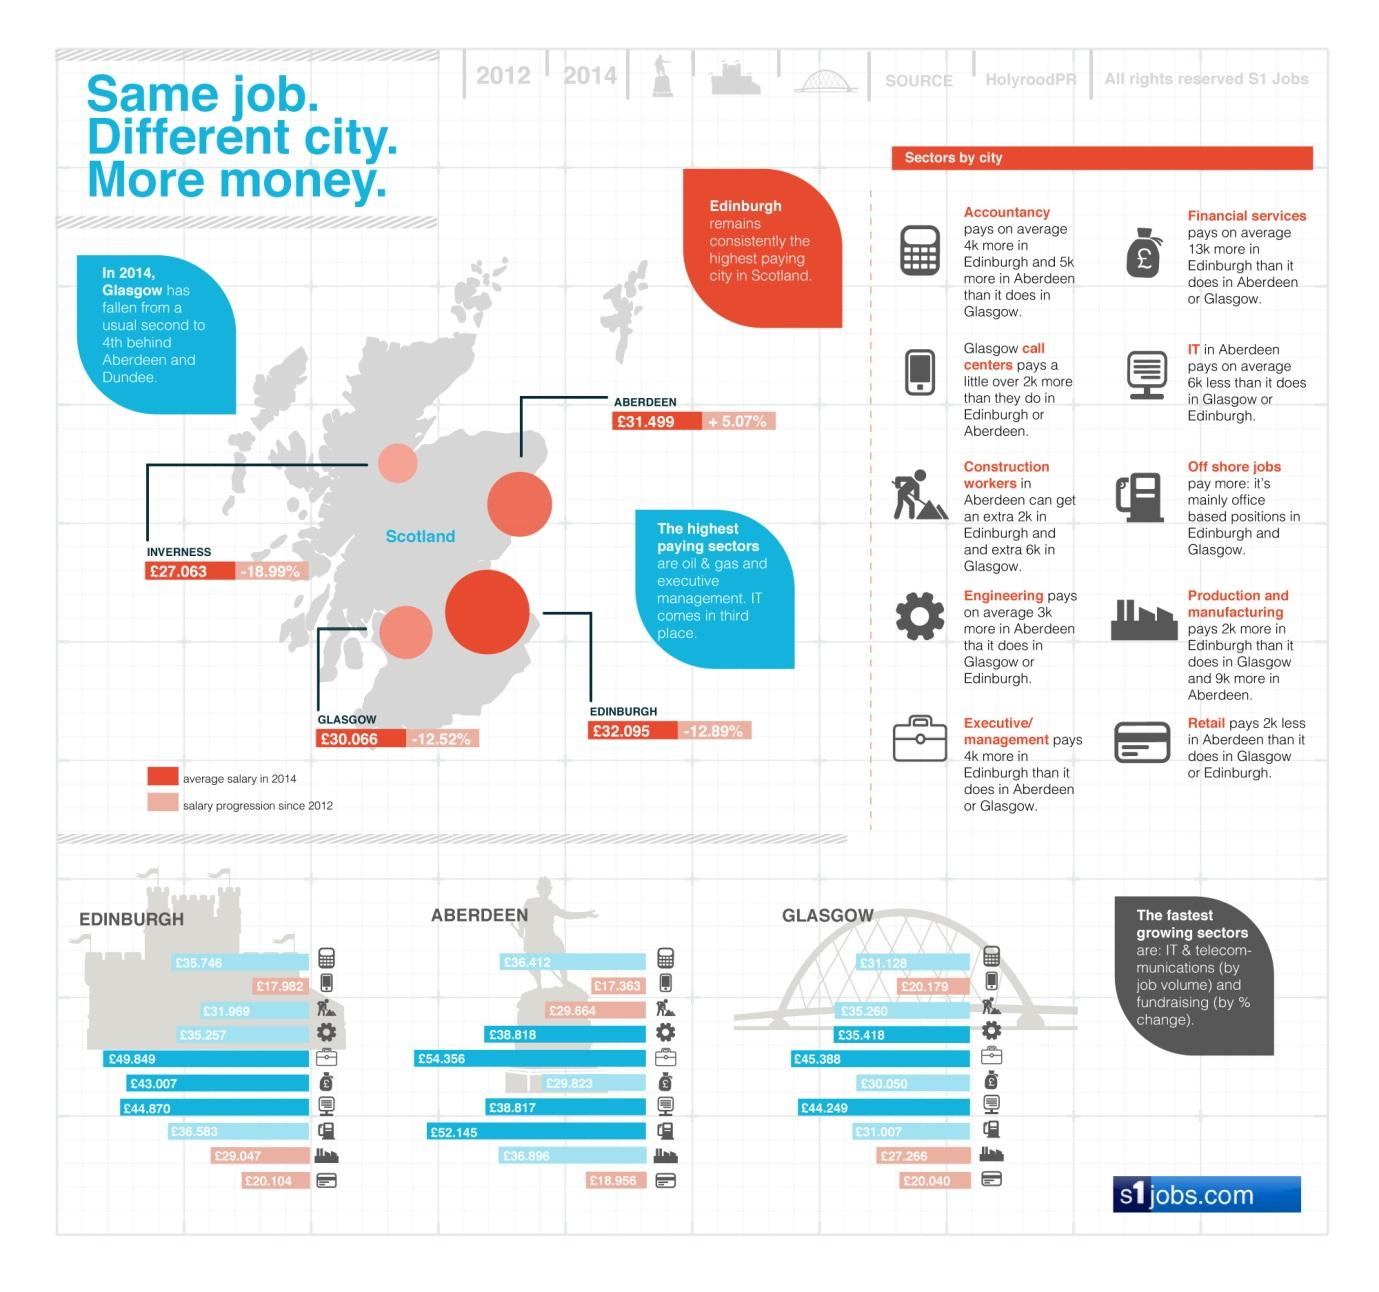Identify some key points in this picture. The salary progression in the city of Glasgow, Scotland from 2012 to 2019 has been negative, with a decrease of 12.52% over the seven-year period. The salary progression in the city of Edinburgh in Scotland have shown a decrease of 12.89% from 2012. According to data from 2014, the average salary paid for engineering jobs in the Aberdeen city was £38,818. The average salary in the accountancy sector in Edinburgh city in 2014 was £35,746. The salary progression in the city of Aberdeen in Scotland from 2012 to 2023 has been an average increase of 5.07%. 